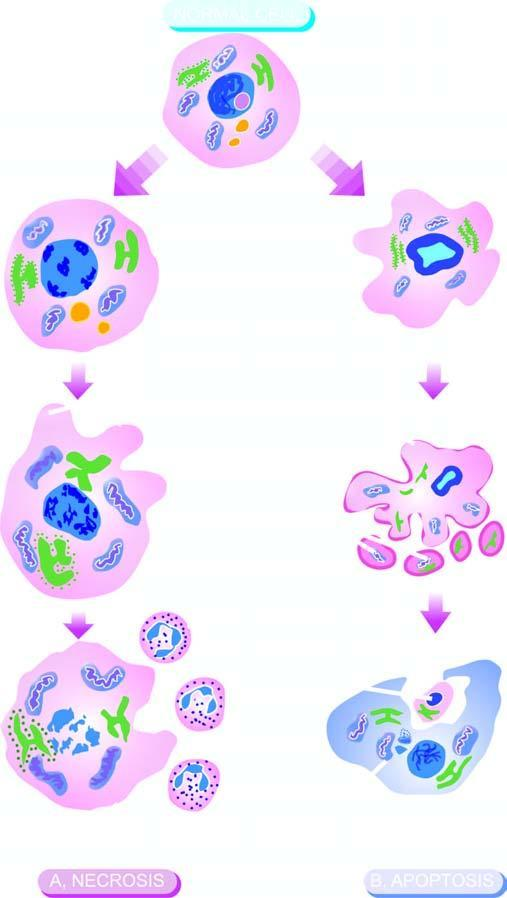do these cells consist of condensation of nuclear chromatin and fragmentation of the cell into membrane-bound apoptotic bodies which are engulfed by macrophages?
Answer the question using a single word or phrase. No 